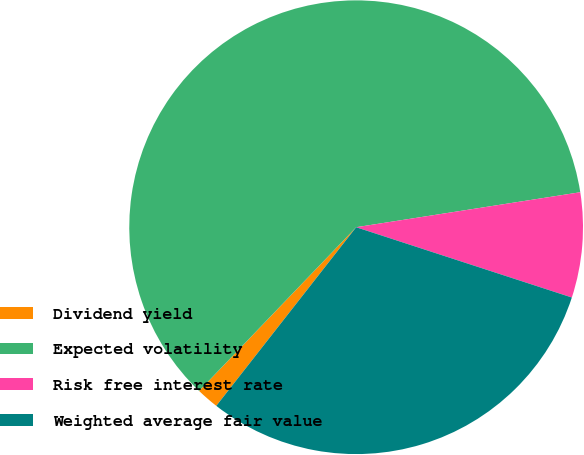<chart> <loc_0><loc_0><loc_500><loc_500><pie_chart><fcel>Dividend yield<fcel>Expected volatility<fcel>Risk free interest rate<fcel>Weighted average fair value<nl><fcel>1.6%<fcel>60.37%<fcel>7.48%<fcel>30.56%<nl></chart> 